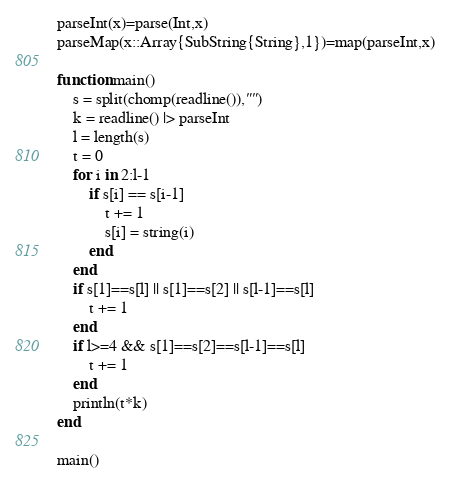<code> <loc_0><loc_0><loc_500><loc_500><_Julia_>parseInt(x)=parse(Int,x)
parseMap(x::Array{SubString{String},1})=map(parseInt,x)

function main()
	s = split(chomp(readline()),"")
	k = readline() |> parseInt
	l = length(s)
	t = 0
	for i in 2:l-1
		if s[i] == s[i-1]
			t += 1
			s[i] = string(i)
		end
	end
	if s[1]==s[l] || s[1]==s[2] || s[l-1]==s[l]
		t += 1
	end
	if l>=4 && s[1]==s[2]==s[l-1]==s[l]
		t += 1
	end
	println(t*k)
end

main()</code> 